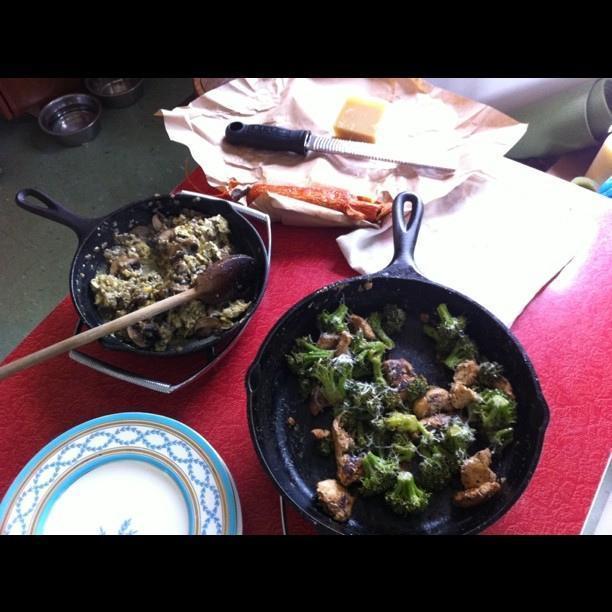How many broccolis are there?
Give a very brief answer. 4. 